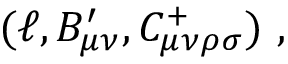Convert formula to latex. <formula><loc_0><loc_0><loc_500><loc_500>( \ell , B _ { \mu \nu } ^ { \prime } , C _ { \mu \nu \rho \sigma } ^ { + } ) \ ,</formula> 